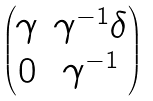<formula> <loc_0><loc_0><loc_500><loc_500>\begin{pmatrix} \gamma & \gamma ^ { - 1 } \delta \\ 0 & \gamma ^ { - 1 } \end{pmatrix}</formula> 